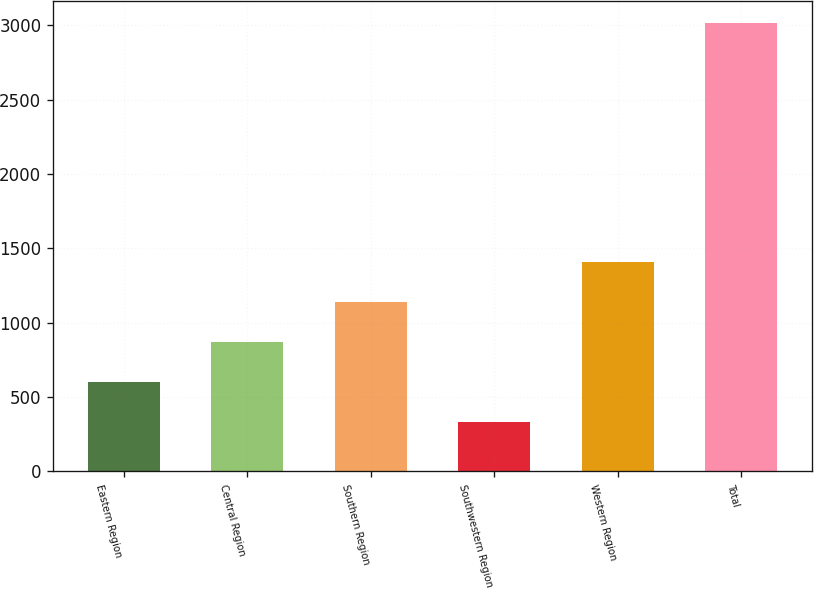Convert chart to OTSL. <chart><loc_0><loc_0><loc_500><loc_500><bar_chart><fcel>Eastern Region<fcel>Central Region<fcel>Southern Region<fcel>Southwestern Region<fcel>Western Region<fcel>Total<nl><fcel>600.78<fcel>868.96<fcel>1137.14<fcel>332.6<fcel>1405.32<fcel>3014.4<nl></chart> 